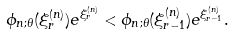Convert formula to latex. <formula><loc_0><loc_0><loc_500><loc_500>\phi _ { n ; \theta } ( \xi _ { r } ^ { ( n ) } ) e ^ { \xi _ { r } ^ { ( n ) } } < \phi _ { n ; \theta } ( \xi _ { r - 1 } ^ { ( n ) } ) e ^ { \xi _ { r - 1 } ^ { ( n ) } } .</formula> 